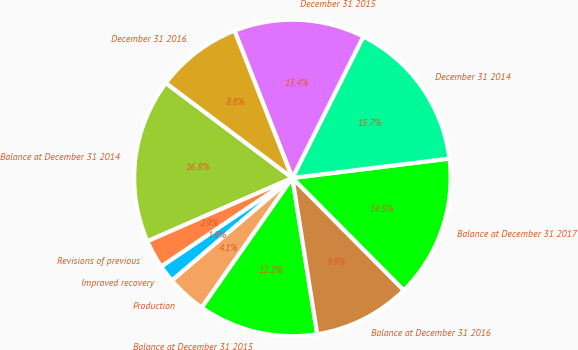Convert chart. <chart><loc_0><loc_0><loc_500><loc_500><pie_chart><fcel>Balance at December 31 2014<fcel>Revisions of previous<fcel>Improved recovery<fcel>Production<fcel>Balance at December 31 2015<fcel>Balance at December 31 2016<fcel>Balance at December 31 2017<fcel>December 31 2014<fcel>December 31 2015<fcel>December 31 2016<nl><fcel>16.79%<fcel>2.91%<fcel>1.77%<fcel>4.06%<fcel>12.22%<fcel>9.93%<fcel>14.51%<fcel>15.65%<fcel>13.36%<fcel>8.79%<nl></chart> 